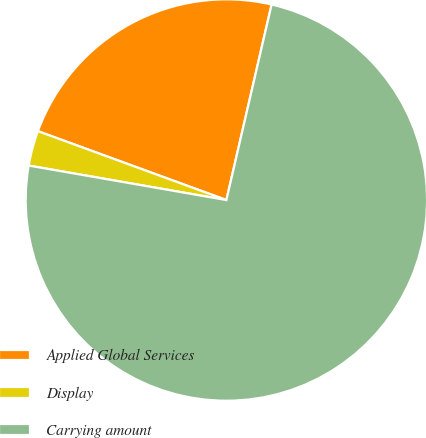Convert chart. <chart><loc_0><loc_0><loc_500><loc_500><pie_chart><fcel>Applied Global Services<fcel>Display<fcel>Carrying amount<nl><fcel>23.04%<fcel>2.83%<fcel>74.13%<nl></chart> 